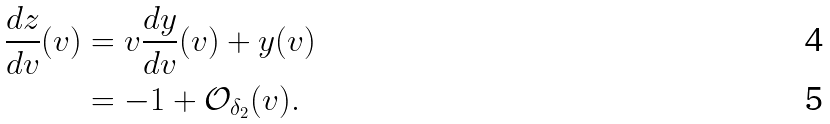Convert formula to latex. <formula><loc_0><loc_0><loc_500><loc_500>\frac { d z } { d v } ( v ) & = v \frac { d y } { d v } ( v ) + y ( v ) \\ & = - 1 + \mathcal { O } _ { \delta _ { 2 } } ( v ) .</formula> 